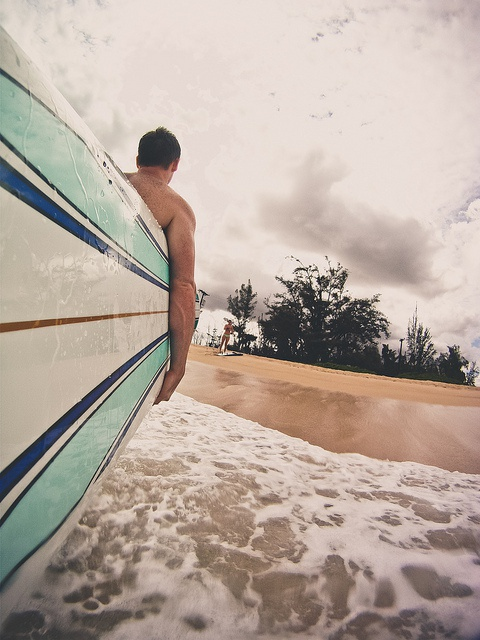Describe the objects in this image and their specific colors. I can see surfboard in lightgray, darkgray, tan, and gray tones, people in lightgray, brown, and black tones, people in lightgray, maroon, and brown tones, and surfboard in lightgray, black, gray, darkgray, and ivory tones in this image. 